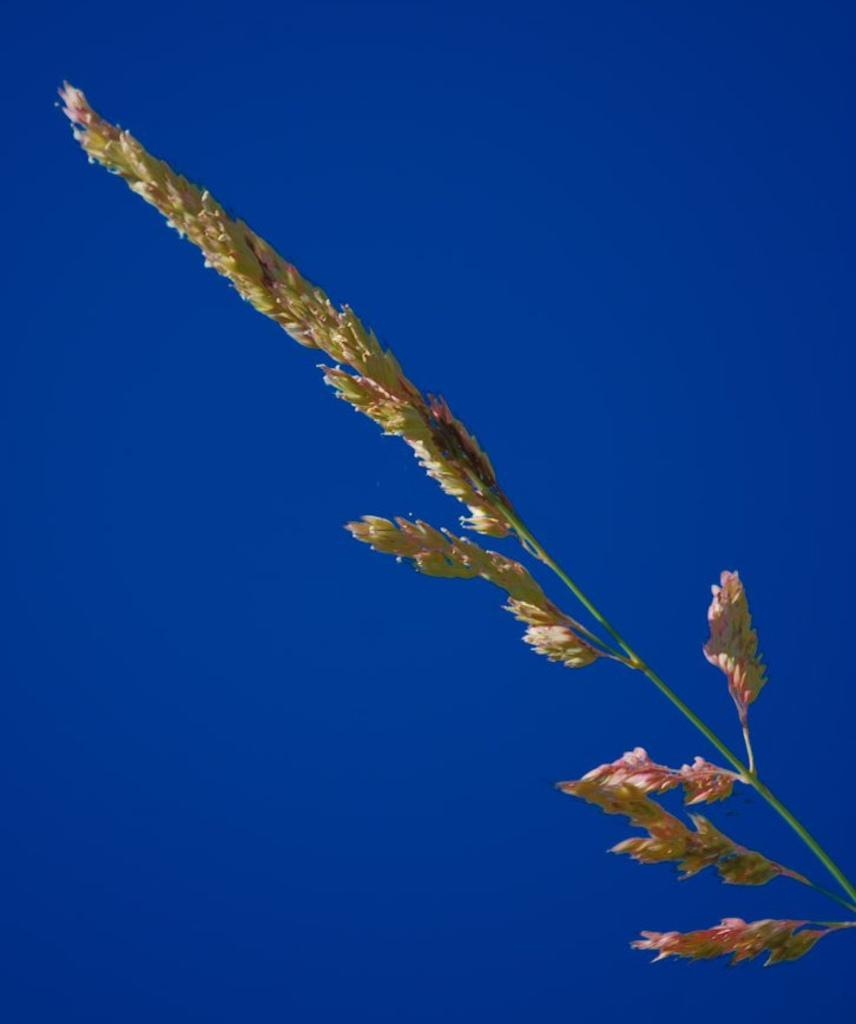What type of living organism can be seen in the image? There is a plant in the image. What is visible at the top of the image? The sky is visible at the top of the image. What is the plant feeling in the image? Plants do not have feelings, so it is not possible to determine what the plant might be feeling. 